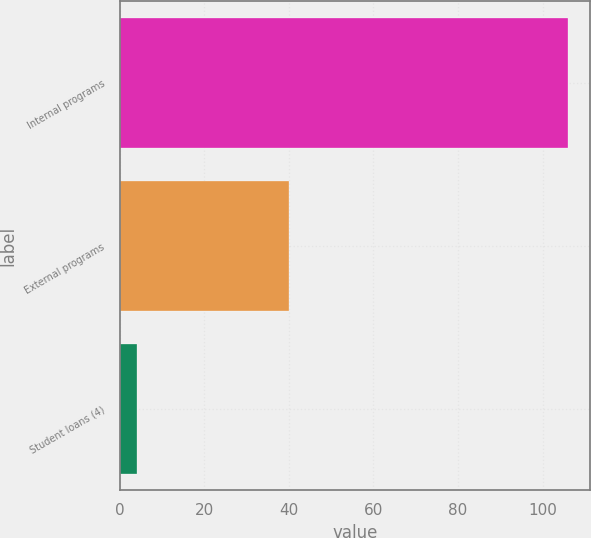<chart> <loc_0><loc_0><loc_500><loc_500><bar_chart><fcel>Internal programs<fcel>External programs<fcel>Student loans (4)<nl><fcel>106<fcel>40<fcel>4<nl></chart> 